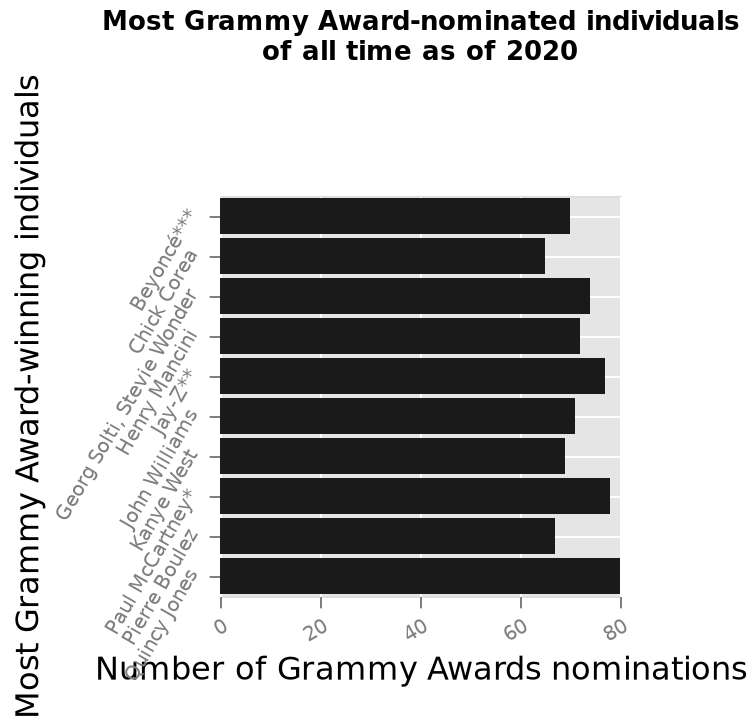<image>
What does the x-axis represent in the bar diagram? The x-axis represents the number of Grammy Awards nominations. 